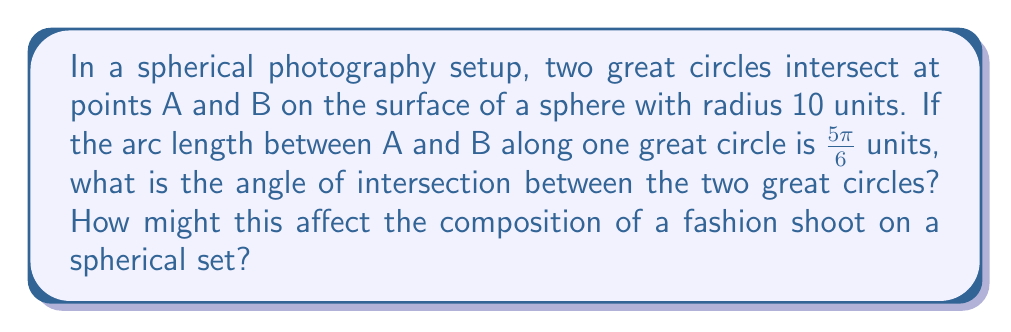Teach me how to tackle this problem. Let's approach this step-by-step:

1) In spherical geometry, the angle between two great circles is equal to the angle between their normal vectors at the point of intersection.

2) The arc length $s$ along a great circle is related to the central angle $θ$ (in radians) by the formula:

   $$s = rθ$$

   where $r$ is the radius of the sphere.

3) We're given that $s = 5π/6$ and $r = 10$. Let's solve for $θ$:

   $$5π/6 = 10θ$$
   $$θ = 5π/60 = π/12$$

4) This central angle $θ$ corresponds to half of the angle of intersection between the great circles. Let's call the angle of intersection $φ$. Then:

   $$φ = 2θ = 2(π/12) = π/6$$

5) Converting to degrees:

   $$φ = (π/6) * (180/π) = 30°$$

This 30° angle could create interesting diagonal lines in the composition, adding dynamism to the fashion shoot. It could be used to guide the viewer's eye or to create a sense of movement in the image.
Answer: $30°$ 